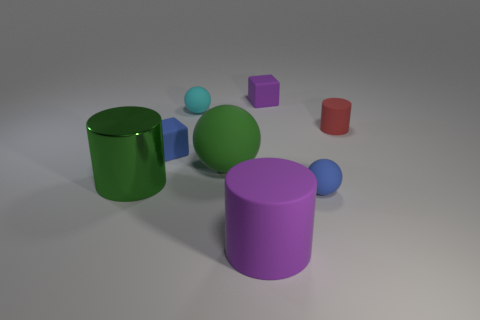Are there the same number of rubber blocks in front of the big rubber cylinder and big cyan rubber blocks?
Provide a short and direct response. Yes. How many small things are in front of the small red object and to the left of the tiny blue rubber sphere?
Your answer should be very brief. 1. What is the size of the green metallic thing that is the same shape as the big purple thing?
Your answer should be very brief. Large. What number of small red cylinders have the same material as the small purple cube?
Your response must be concise. 1. Is the number of purple things behind the shiny cylinder less than the number of matte blocks?
Provide a succinct answer. Yes. How many large shiny balls are there?
Provide a short and direct response. 0. How many other things are the same color as the big metallic object?
Ensure brevity in your answer.  1. Is the shape of the red thing the same as the green metal thing?
Your answer should be very brief. Yes. There is a cylinder to the left of the big green object that is on the right side of the blue block; how big is it?
Ensure brevity in your answer.  Large. Are there any gray metal objects of the same size as the green rubber object?
Give a very brief answer. No. 